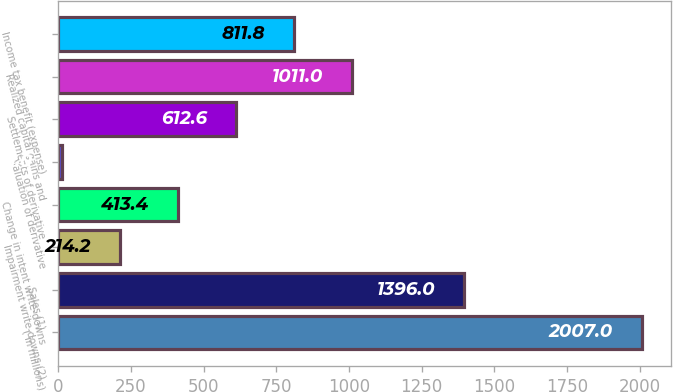<chart> <loc_0><loc_0><loc_500><loc_500><bar_chart><fcel>( in millions)<fcel>Sales (1)<fcel>Impairment write-downs (2)<fcel>Change in intent write-downs<fcel>Valuation of derivative<fcel>Settlements of derivative<fcel>Realized capital gains and<fcel>Income tax benefit (expense)<nl><fcel>2007<fcel>1396<fcel>214.2<fcel>413.4<fcel>15<fcel>612.6<fcel>1011<fcel>811.8<nl></chart> 